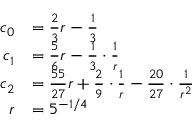Convert formula to latex. <formula><loc_0><loc_0><loc_500><loc_500>\begin{array} { r l } { c _ { 0 } } & { = \frac { 2 } { 3 } r - \frac { 1 } { 3 } } \\ { c _ { 1 } } & { = \frac { 5 } { 6 } r - \frac { 1 } { 3 } \cdot \frac { 1 } { r } } \\ { c _ { 2 } } & { = \frac { 5 5 } { 2 7 } r + \frac { 2 } { 9 } \cdot \frac { 1 } { r } - \frac { 2 0 } { 2 7 } \cdot \frac { 1 } { r ^ { 2 } } } \\ { r } & { = 5 ^ { - 1 / 4 } } \end{array}</formula> 